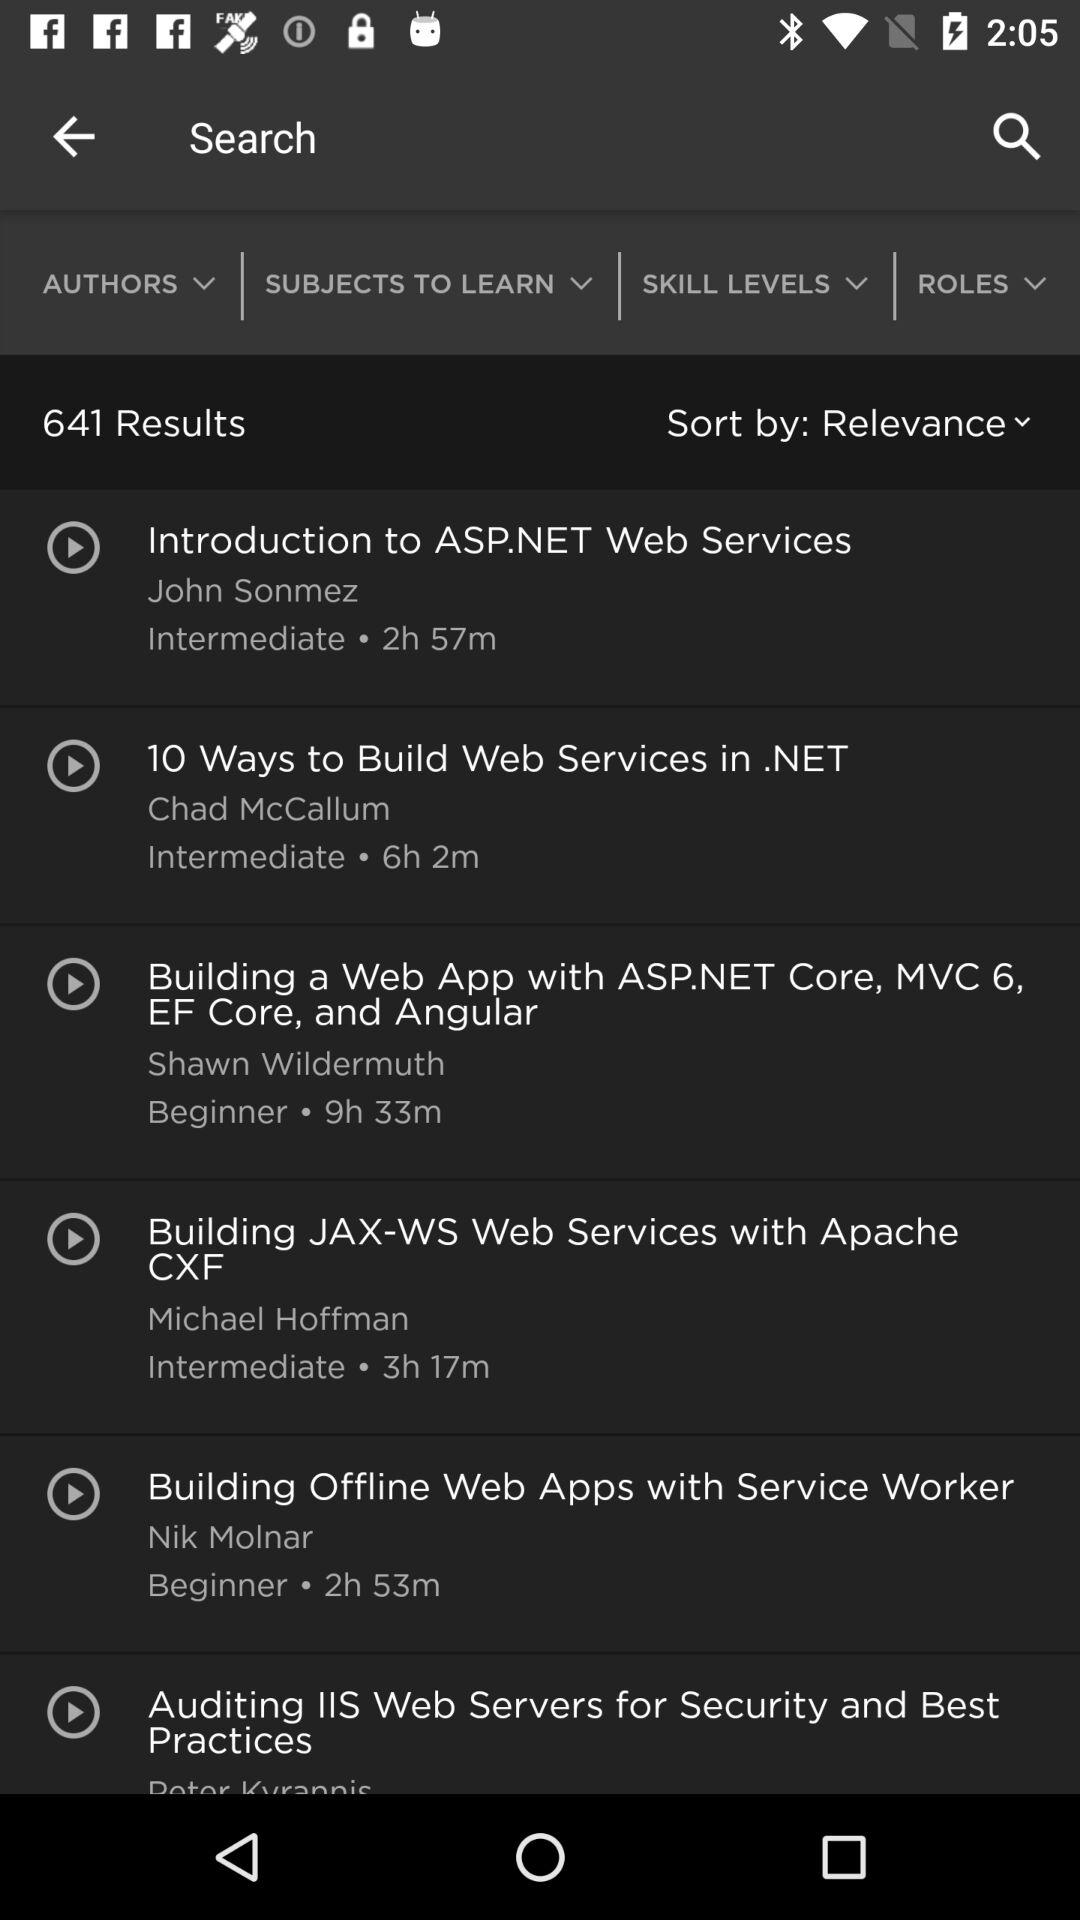Who is the author of "Introduction to ASP.NET Web Services"? The author is John Sonmez. 